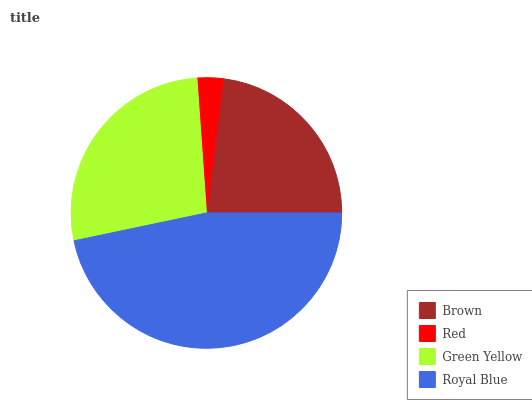Is Red the minimum?
Answer yes or no. Yes. Is Royal Blue the maximum?
Answer yes or no. Yes. Is Green Yellow the minimum?
Answer yes or no. No. Is Green Yellow the maximum?
Answer yes or no. No. Is Green Yellow greater than Red?
Answer yes or no. Yes. Is Red less than Green Yellow?
Answer yes or no. Yes. Is Red greater than Green Yellow?
Answer yes or no. No. Is Green Yellow less than Red?
Answer yes or no. No. Is Green Yellow the high median?
Answer yes or no. Yes. Is Brown the low median?
Answer yes or no. Yes. Is Royal Blue the high median?
Answer yes or no. No. Is Red the low median?
Answer yes or no. No. 